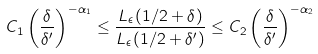<formula> <loc_0><loc_0><loc_500><loc_500>C _ { 1 } \left ( \frac { \delta } { \delta ^ { \prime } } \right ) ^ { - \alpha _ { 1 } } \leq \frac { L _ { \epsilon } ( 1 / 2 + \delta ) } { L _ { \epsilon } ( 1 / 2 + \delta ^ { \prime } ) } \leq C _ { 2 } \left ( \frac { \delta } { \delta ^ { \prime } } \right ) ^ { - \alpha _ { 2 } }</formula> 